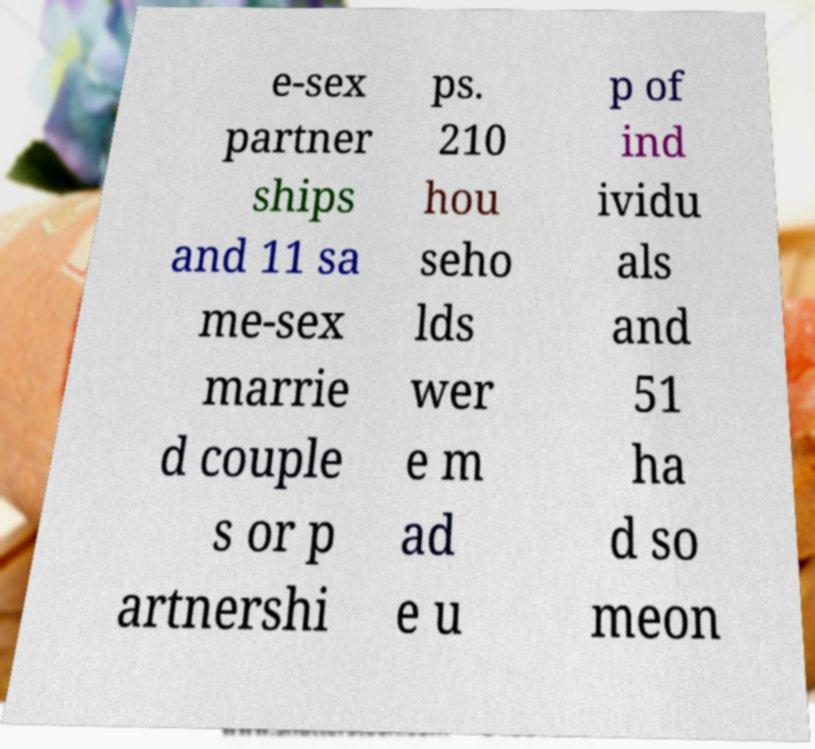Please identify and transcribe the text found in this image. e-sex partner ships and 11 sa me-sex marrie d couple s or p artnershi ps. 210 hou seho lds wer e m ad e u p of ind ividu als and 51 ha d so meon 